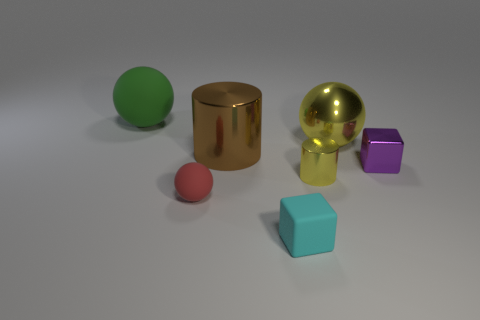Subtract all tiny balls. How many balls are left? 2 Subtract all yellow cylinders. How many cylinders are left? 1 Add 1 small yellow shiny balls. How many objects exist? 8 Subtract 1 cylinders. How many cylinders are left? 1 Subtract all gray balls. How many blue cylinders are left? 0 Subtract all tiny red metal spheres. Subtract all big green matte things. How many objects are left? 6 Add 5 big yellow shiny things. How many big yellow shiny things are left? 6 Add 1 small rubber objects. How many small rubber objects exist? 3 Subtract 0 red cubes. How many objects are left? 7 Subtract all balls. How many objects are left? 4 